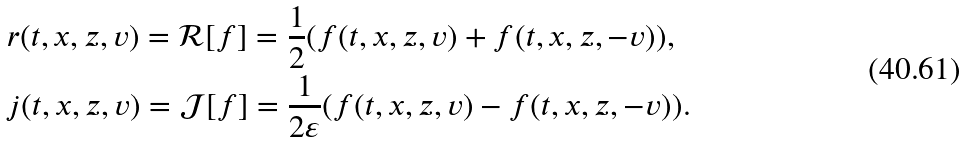<formula> <loc_0><loc_0><loc_500><loc_500>& r ( t , x , z , v ) = \mathcal { R } [ f ] = \frac { 1 } { 2 } ( f ( t , x , z , v ) + f ( t , x , z , - v ) ) , \\ & j ( t , x , z , v ) = \mathcal { J } [ f ] = \frac { 1 } { 2 \varepsilon } ( f ( t , x , z , v ) - f ( t , x , z , - v ) ) .</formula> 